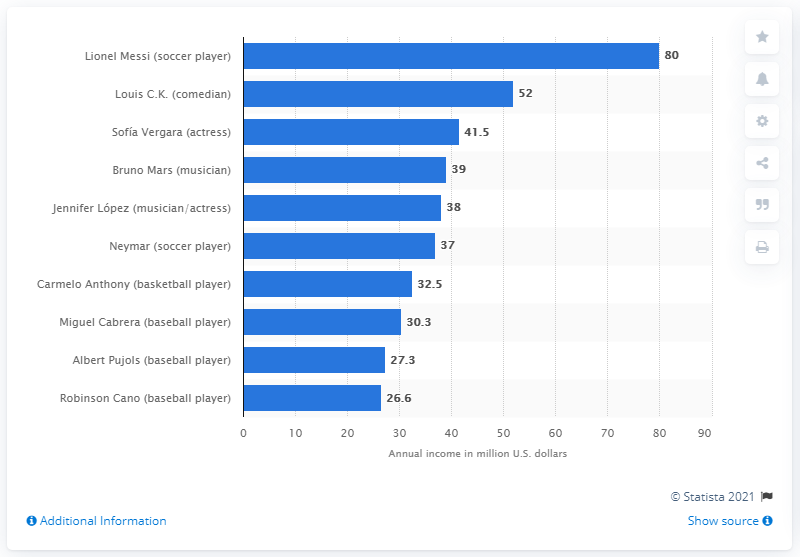Mention a couple of crucial points in this snapshot. Sofa Vergara earned $41.5 million in 2017. 